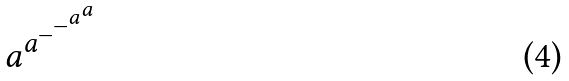Convert formula to latex. <formula><loc_0><loc_0><loc_500><loc_500>a ^ { a ^ { - ^ { - ^ { a ^ { a } } } } }</formula> 